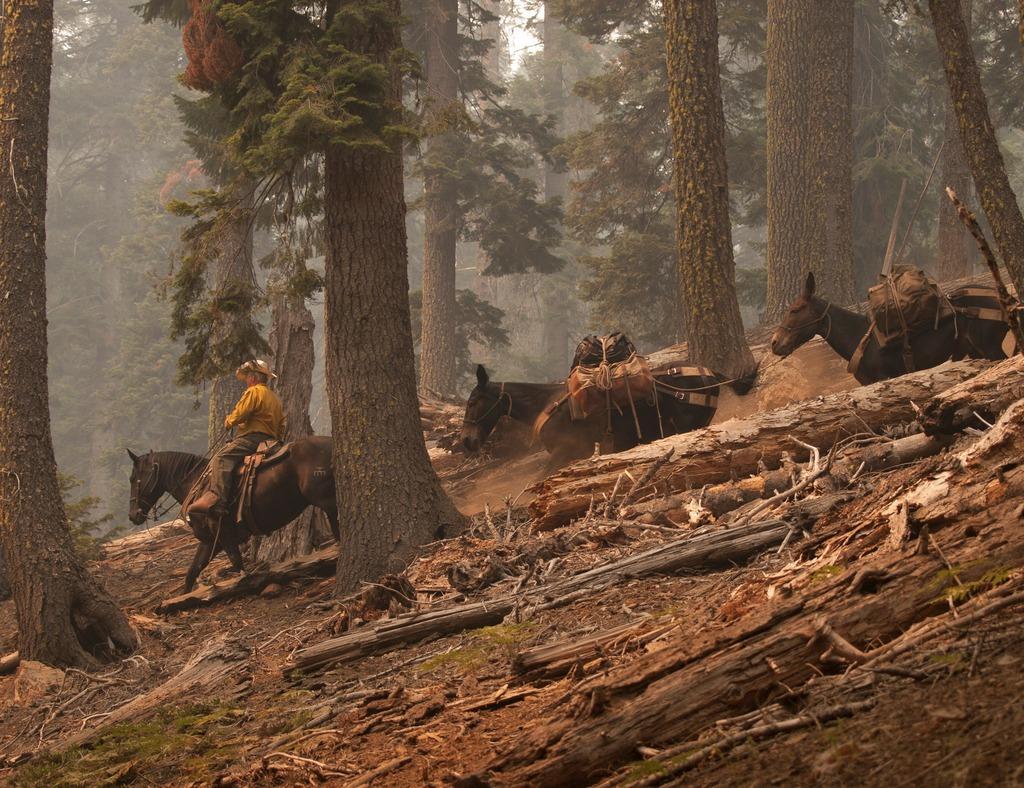How would you summarize this image in a sentence or two? In this picture we can see wooden barks, few horses and a man, he is seated on the horse, in the background we can see few trees. 